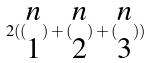<formula> <loc_0><loc_0><loc_500><loc_500>2 ( ( \begin{matrix} n \\ 1 \end{matrix} ) + ( \begin{matrix} n \\ 2 \end{matrix} ) + ( \begin{matrix} n \\ 3 \end{matrix} ) )</formula> 